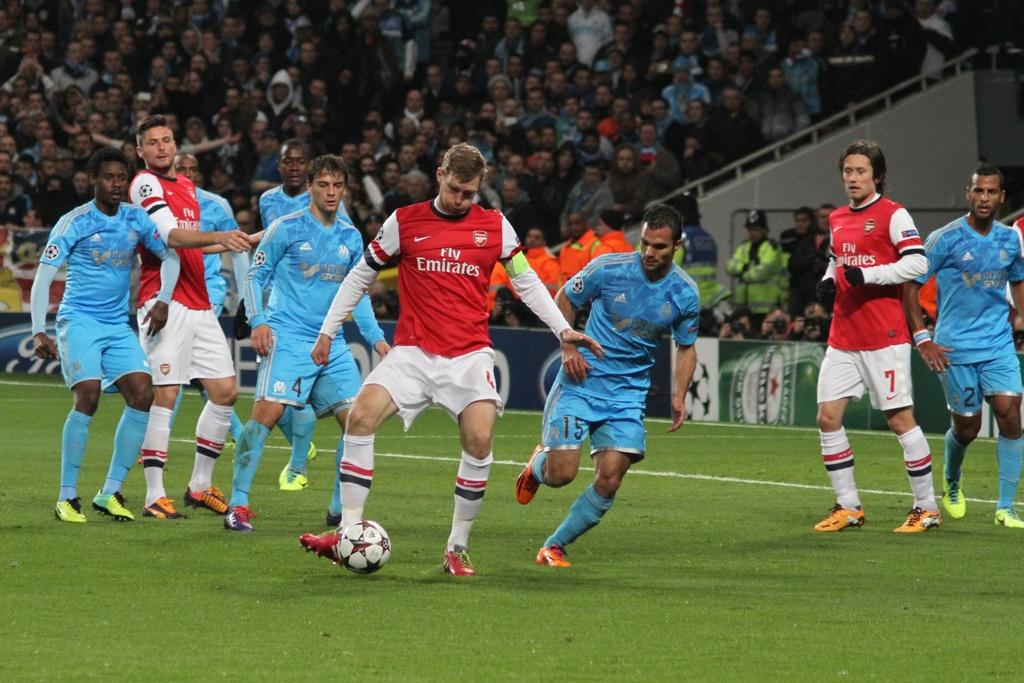<image>
Create a compact narrative representing the image presented. A soccer player in a red Fly Emirates jersey kicks the ball as a player in a blue jersey approaches 